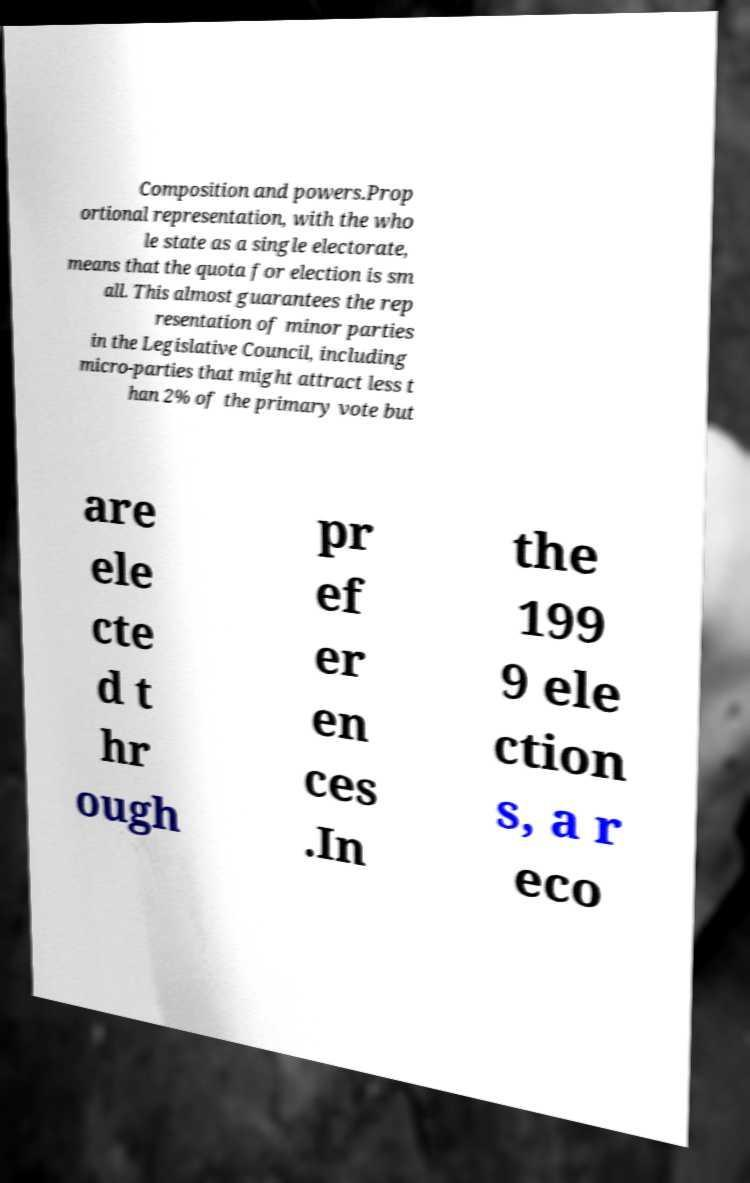There's text embedded in this image that I need extracted. Can you transcribe it verbatim? Composition and powers.Prop ortional representation, with the who le state as a single electorate, means that the quota for election is sm all. This almost guarantees the rep resentation of minor parties in the Legislative Council, including micro-parties that might attract less t han 2% of the primary vote but are ele cte d t hr ough pr ef er en ces .In the 199 9 ele ction s, a r eco 